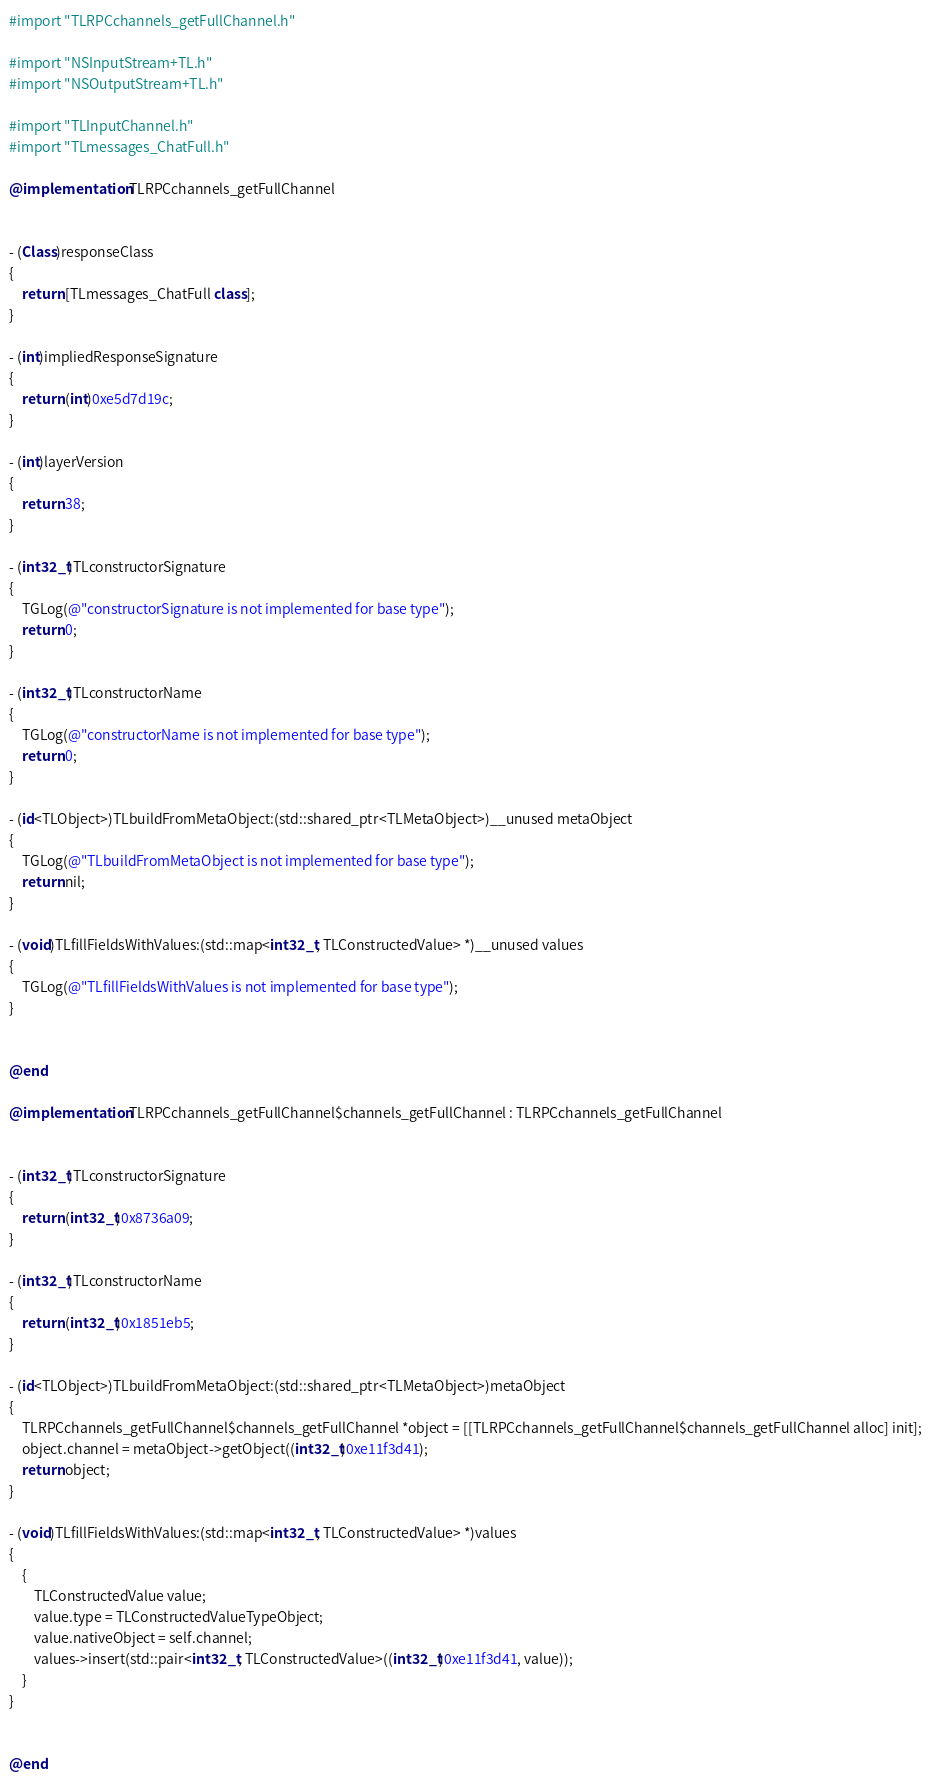Convert code to text. <code><loc_0><loc_0><loc_500><loc_500><_ObjectiveC_>#import "TLRPCchannels_getFullChannel.h"

#import "NSInputStream+TL.h"
#import "NSOutputStream+TL.h"

#import "TLInputChannel.h"
#import "TLmessages_ChatFull.h"

@implementation TLRPCchannels_getFullChannel


- (Class)responseClass
{
    return [TLmessages_ChatFull class];
}

- (int)impliedResponseSignature
{
    return (int)0xe5d7d19c;
}

- (int)layerVersion
{
    return 38;
}

- (int32_t)TLconstructorSignature
{
    TGLog(@"constructorSignature is not implemented for base type");
    return 0;
}

- (int32_t)TLconstructorName
{
    TGLog(@"constructorName is not implemented for base type");
    return 0;
}

- (id<TLObject>)TLbuildFromMetaObject:(std::shared_ptr<TLMetaObject>)__unused metaObject
{
    TGLog(@"TLbuildFromMetaObject is not implemented for base type");
    return nil;
}

- (void)TLfillFieldsWithValues:(std::map<int32_t, TLConstructedValue> *)__unused values
{
    TGLog(@"TLfillFieldsWithValues is not implemented for base type");
}


@end

@implementation TLRPCchannels_getFullChannel$channels_getFullChannel : TLRPCchannels_getFullChannel


- (int32_t)TLconstructorSignature
{
    return (int32_t)0x8736a09;
}

- (int32_t)TLconstructorName
{
    return (int32_t)0x1851eb5;
}

- (id<TLObject>)TLbuildFromMetaObject:(std::shared_ptr<TLMetaObject>)metaObject
{
    TLRPCchannels_getFullChannel$channels_getFullChannel *object = [[TLRPCchannels_getFullChannel$channels_getFullChannel alloc] init];
    object.channel = metaObject->getObject((int32_t)0xe11f3d41);
    return object;
}

- (void)TLfillFieldsWithValues:(std::map<int32_t, TLConstructedValue> *)values
{
    {
        TLConstructedValue value;
        value.type = TLConstructedValueTypeObject;
        value.nativeObject = self.channel;
        values->insert(std::pair<int32_t, TLConstructedValue>((int32_t)0xe11f3d41, value));
    }
}


@end

</code> 